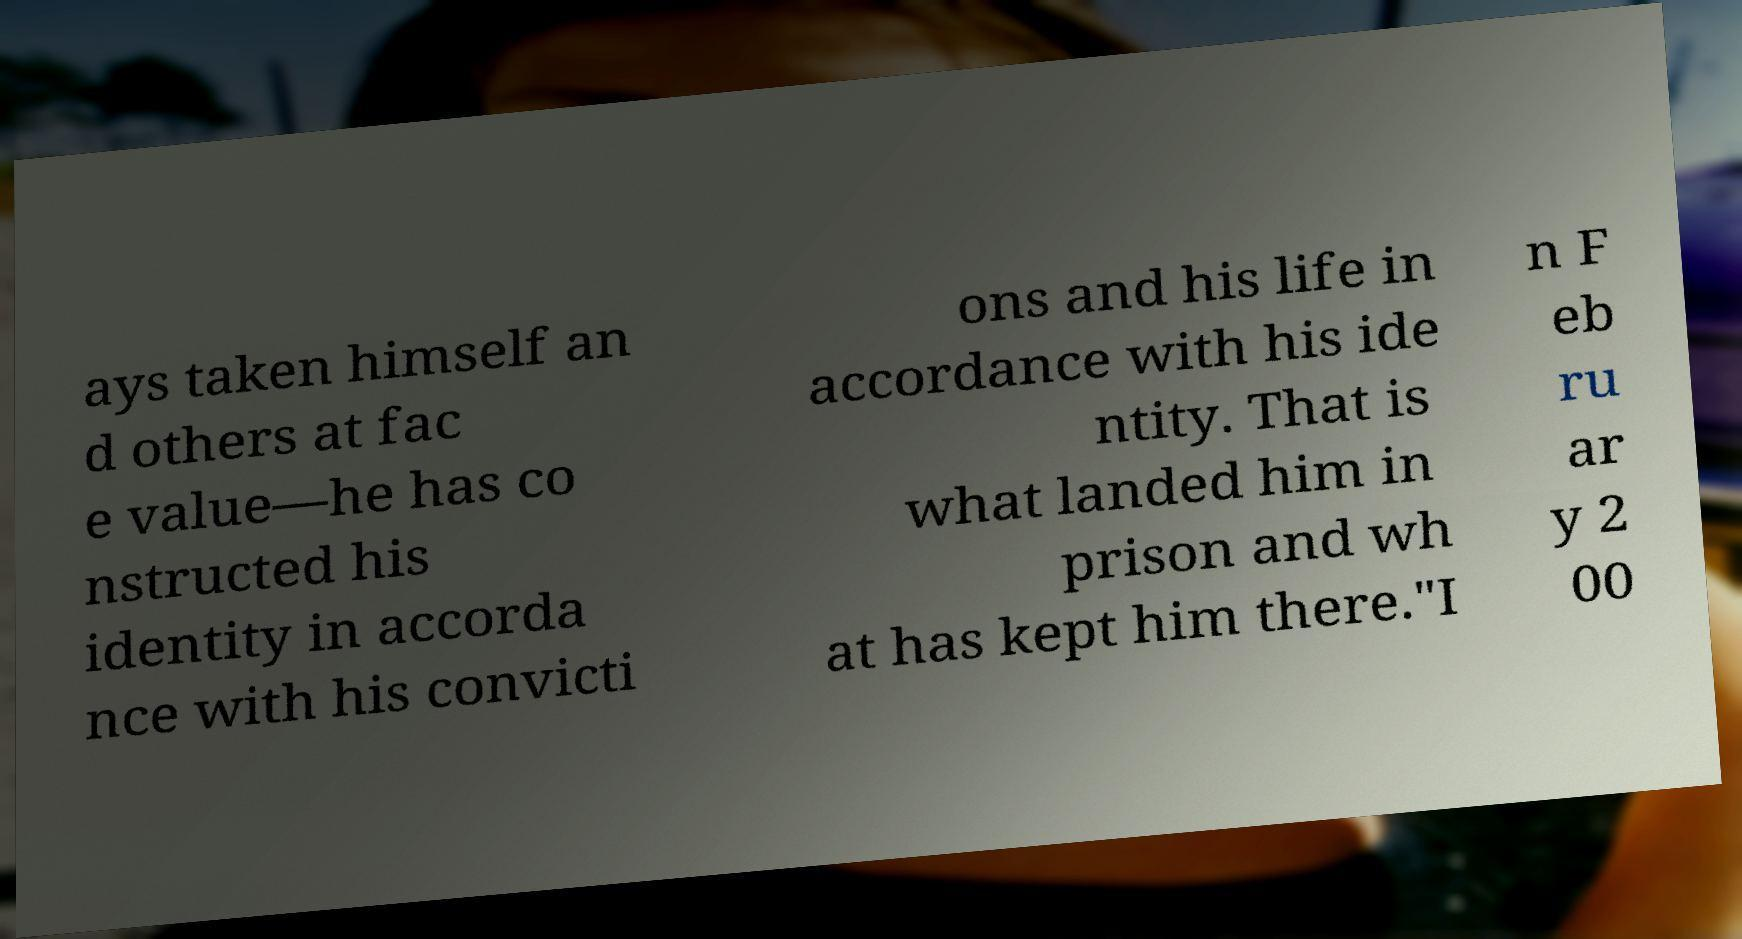Please read and relay the text visible in this image. What does it say? ays taken himself an d others at fac e value—he has co nstructed his identity in accorda nce with his convicti ons and his life in accordance with his ide ntity. That is what landed him in prison and wh at has kept him there."I n F eb ru ar y 2 00 